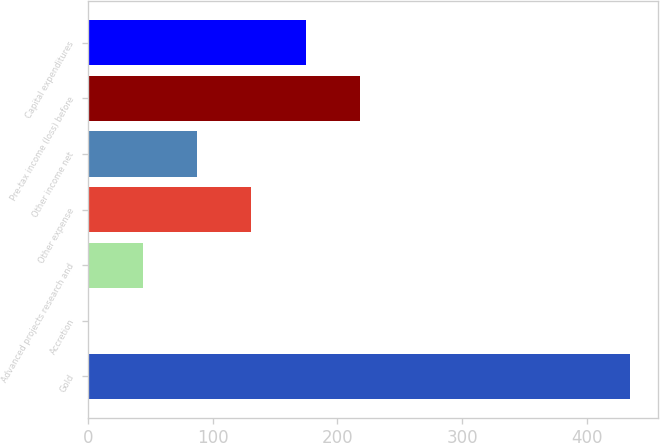Convert chart. <chart><loc_0><loc_0><loc_500><loc_500><bar_chart><fcel>Gold<fcel>Accretion<fcel>Advanced projects research and<fcel>Other expense<fcel>Other income net<fcel>Pre-tax income (loss) before<fcel>Capital expenditures<nl><fcel>435<fcel>1<fcel>44.4<fcel>131.2<fcel>87.8<fcel>218<fcel>174.6<nl></chart> 